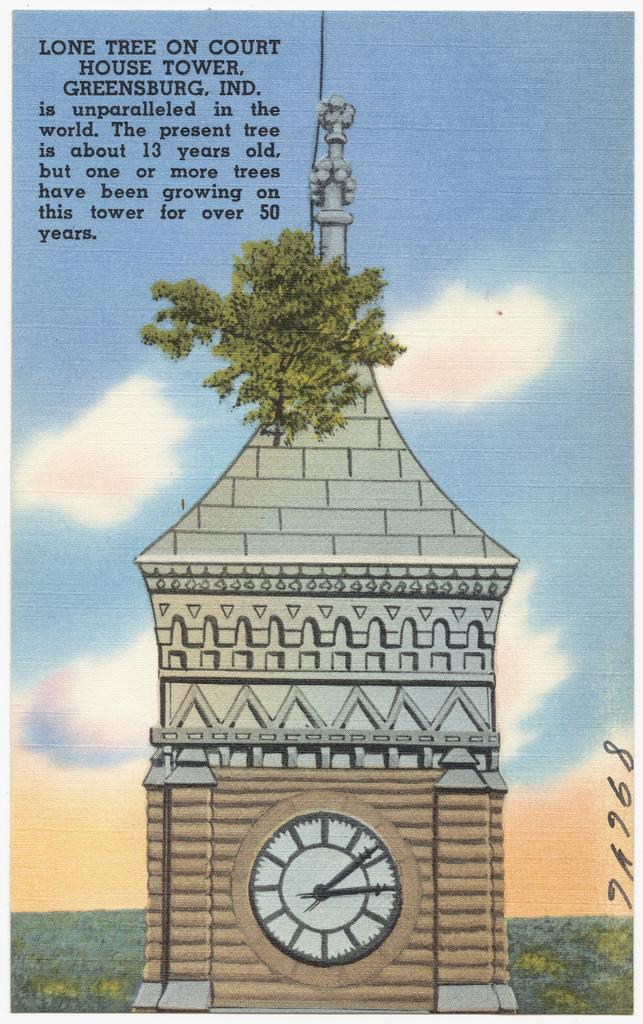What is the main structure in the image? There is a clock tower in the image. What type of vegetation can be seen in the background? There are plants in the background of the image, with a green color. What colors are visible in the sky? The sky is visible in the image, with blue and white colors. Is there any text or writing present in the image? Yes, there is text or writing present in the image. Where is the spot on the boot in the image? There is no boot or spot present in the image. 